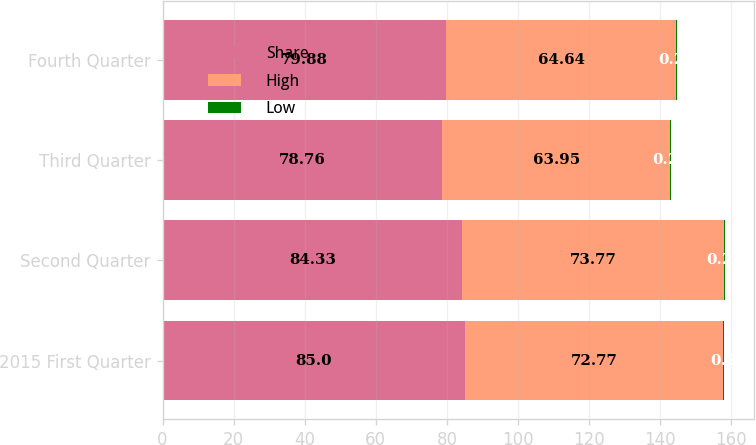<chart> <loc_0><loc_0><loc_500><loc_500><stacked_bar_chart><ecel><fcel>2015 First Quarter<fcel>Second Quarter<fcel>Third Quarter<fcel>Fourth Quarter<nl><fcel>Share<fcel>85<fcel>84.33<fcel>78.76<fcel>79.88<nl><fcel>High<fcel>72.77<fcel>73.77<fcel>63.95<fcel>64.64<nl><fcel>Low<fcel>0.2<fcel>0.25<fcel>0.25<fcel>0.25<nl></chart> 